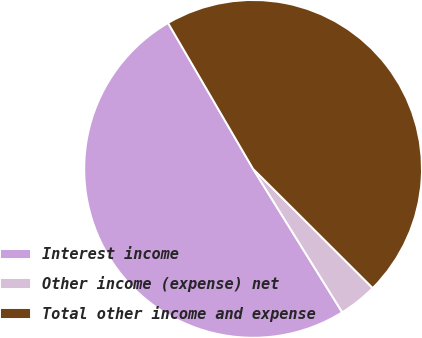<chart> <loc_0><loc_0><loc_500><loc_500><pie_chart><fcel>Interest income<fcel>Other income (expense) net<fcel>Total other income and expense<nl><fcel>50.46%<fcel>3.68%<fcel>45.87%<nl></chart> 